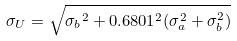Convert formula to latex. <formula><loc_0><loc_0><loc_500><loc_500>\sigma _ { U } = \sqrt { { \sigma _ { b } } ^ { 2 } + 0 . 6 8 0 1 ^ { 2 } ( \sigma _ { a } ^ { 2 } + \sigma _ { b } ^ { 2 } ) }</formula> 